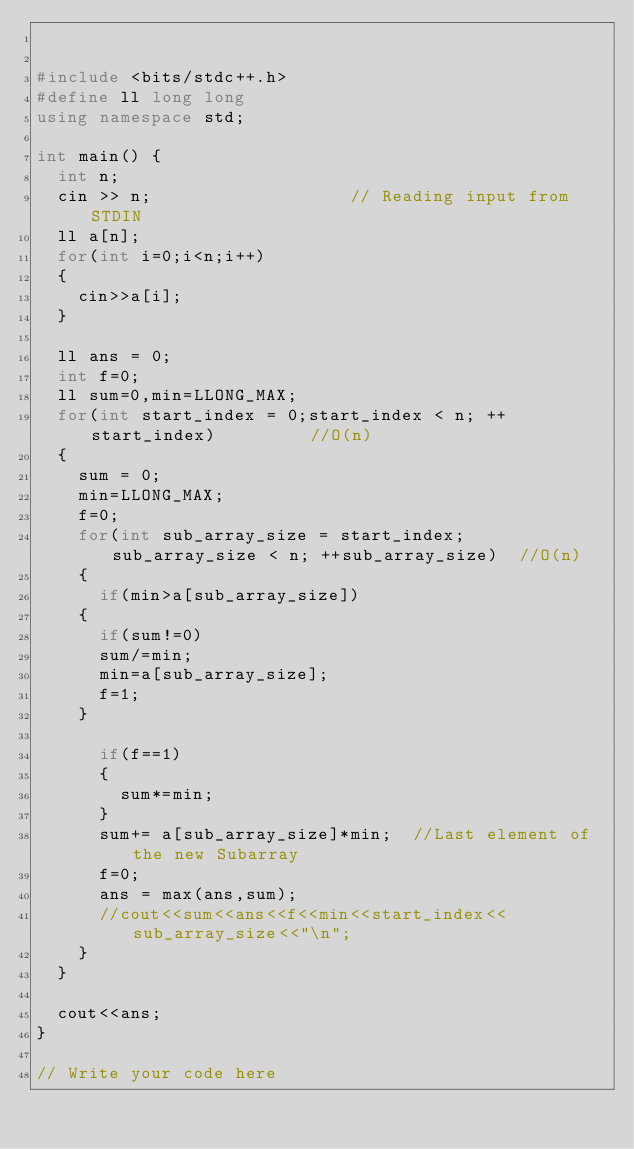Convert code to text. <code><loc_0><loc_0><loc_500><loc_500><_C++_>

#include <bits/stdc++.h>
#define ll long long
using namespace std;

int main() {
	int n;
	cin >> n;										// Reading input from STDIN
	ll a[n];
	for(int i=0;i<n;i++)
	{
		cin>>a[i];
	}

	ll ans = 0;
	int f=0;
	ll sum=0,min=LLONG_MAX;
	for(int start_index = 0;start_index < n; ++start_index)					//O(n)		
	{
		sum = 0;
		min=LLONG_MAX;
		f=0;
		for(int sub_array_size = start_index;sub_array_size < n; ++sub_array_size)	//O(n)	
		{
			if(min>a[sub_array_size])
		{
			if(sum!=0)
			sum/=min;
			min=a[sub_array_size];
			f=1;
		}

			if(f==1)
			{
				sum*=min;
			}
			sum+= a[sub_array_size]*min;	//Last element of the new Subarray
			f=0;
			ans = max(ans,sum);
			//cout<<sum<<ans<<f<<min<<start_index<<sub_array_size<<"\n";
		}
	}

	cout<<ans;
}

// Write your code here

</code> 